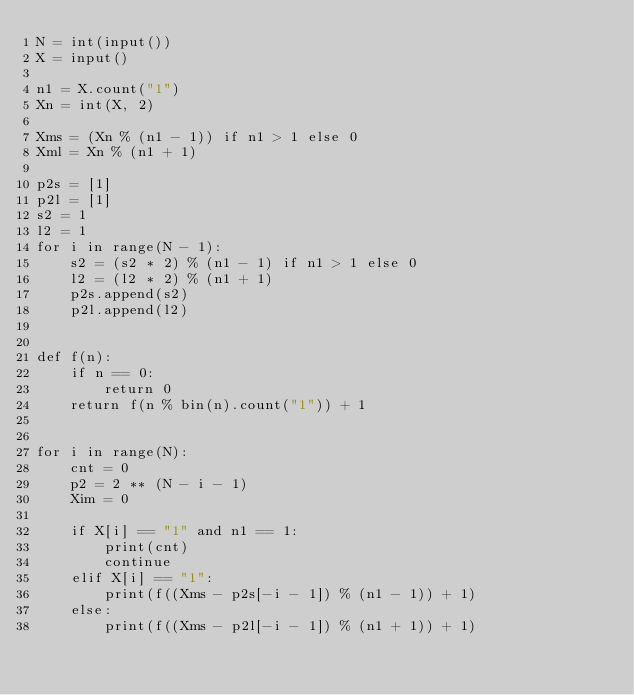<code> <loc_0><loc_0><loc_500><loc_500><_Python_>N = int(input())
X = input()

n1 = X.count("1")
Xn = int(X, 2)

Xms = (Xn % (n1 - 1)) if n1 > 1 else 0
Xml = Xn % (n1 + 1)

p2s = [1]
p2l = [1]
s2 = 1
l2 = 1
for i in range(N - 1):
    s2 = (s2 * 2) % (n1 - 1) if n1 > 1 else 0
    l2 = (l2 * 2) % (n1 + 1)
    p2s.append(s2)
    p2l.append(l2)


def f(n):
    if n == 0:
        return 0
    return f(n % bin(n).count("1")) + 1


for i in range(N):
    cnt = 0
    p2 = 2 ** (N - i - 1)
    Xim = 0

    if X[i] == "1" and n1 == 1:
        print(cnt)
        continue
    elif X[i] == "1":
        print(f((Xms - p2s[-i - 1]) % (n1 - 1)) + 1)
    else:
        print(f((Xms - p2l[-i - 1]) % (n1 + 1)) + 1)

</code> 